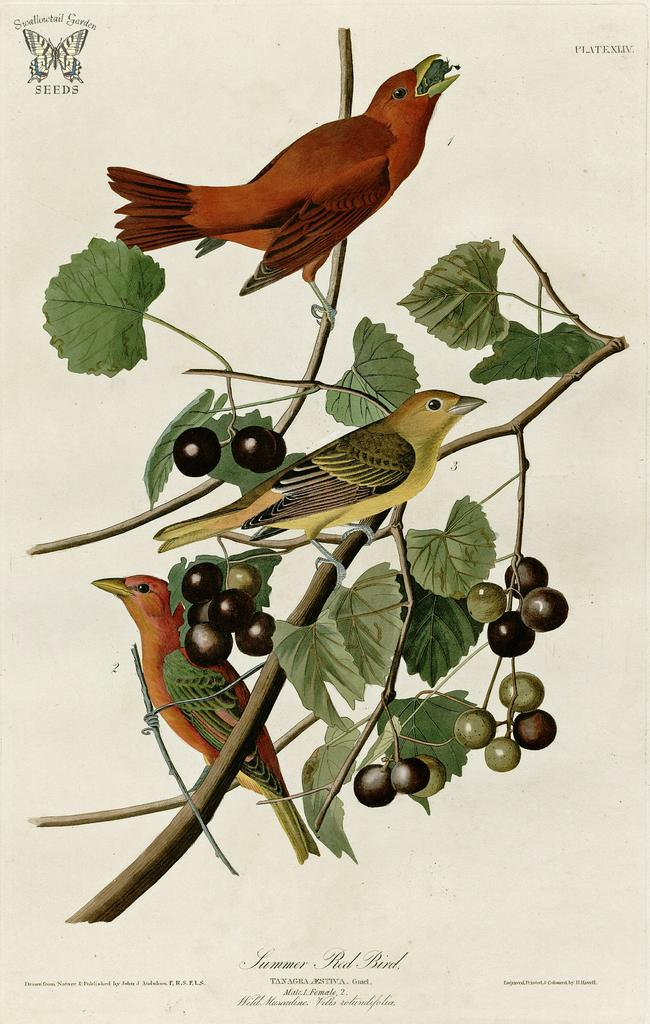What is the main subject of the poster in the image? The poster contains birds standing on branches. What other elements are present in the poster? The poster includes leaves, objects that resemble fruits, words, and a symbol. Can you tell me how many beds are depicted in the poster? There are no beds present in the poster; it features birds, leaves, fruits, words, and a symbol. 